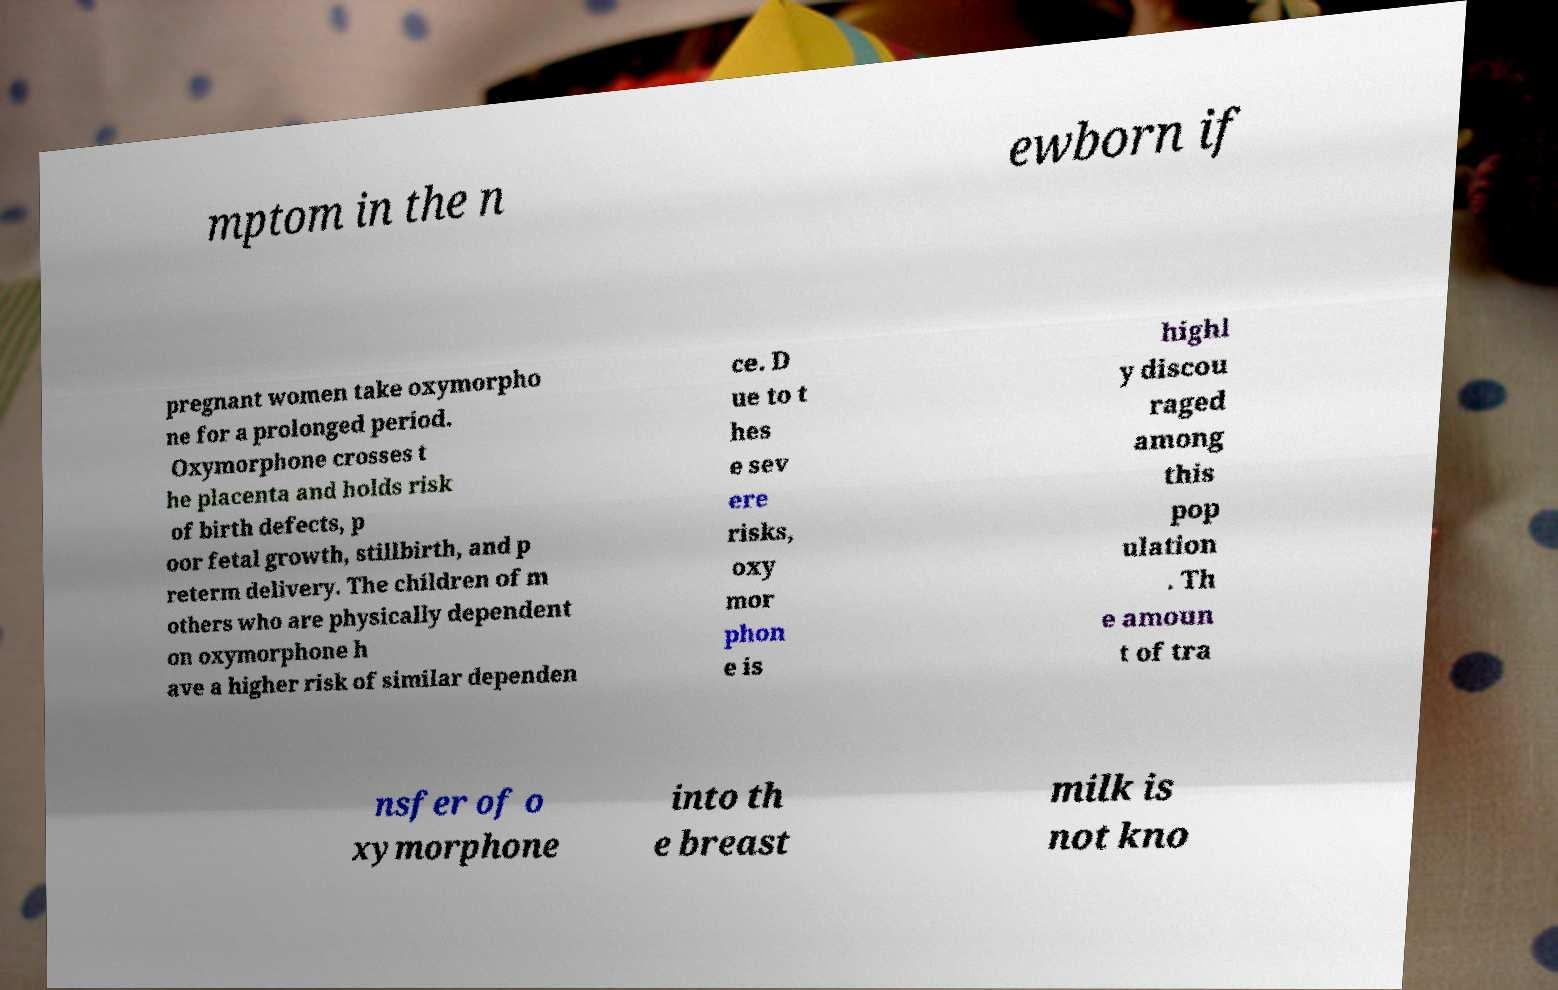For documentation purposes, I need the text within this image transcribed. Could you provide that? mptom in the n ewborn if pregnant women take oxymorpho ne for a prolonged period. Oxymorphone crosses t he placenta and holds risk of birth defects, p oor fetal growth, stillbirth, and p reterm delivery. The children of m others who are physically dependent on oxymorphone h ave a higher risk of similar dependen ce. D ue to t hes e sev ere risks, oxy mor phon e is highl y discou raged among this pop ulation . Th e amoun t of tra nsfer of o xymorphone into th e breast milk is not kno 